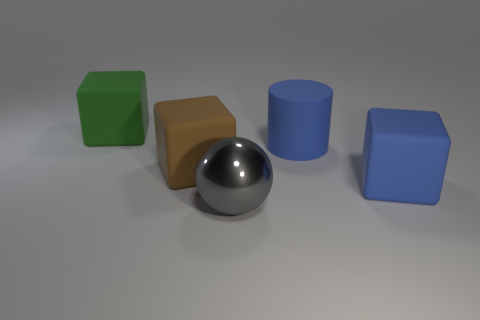Is the number of objects to the left of the large green cube the same as the number of objects behind the large ball?
Keep it short and to the point. No. The object that is in front of the big rubber block in front of the brown rubber cube is made of what material?
Offer a terse response. Metal. How many objects are metal things or green blocks?
Make the answer very short. 2. The rubber thing that is the same color as the matte cylinder is what size?
Keep it short and to the point. Large. Is the number of big blue matte cubes less than the number of big purple matte cylinders?
Give a very brief answer. No. There is a blue thing that is the same material as the large blue cylinder; what is its size?
Give a very brief answer. Large. The brown thing is what size?
Ensure brevity in your answer.  Large. What shape is the large metal object?
Ensure brevity in your answer.  Sphere. Does the block that is right of the metallic sphere have the same color as the big shiny sphere?
Offer a terse response. No. There is a blue matte thing that is the same shape as the big green object; what size is it?
Offer a very short reply. Large. 